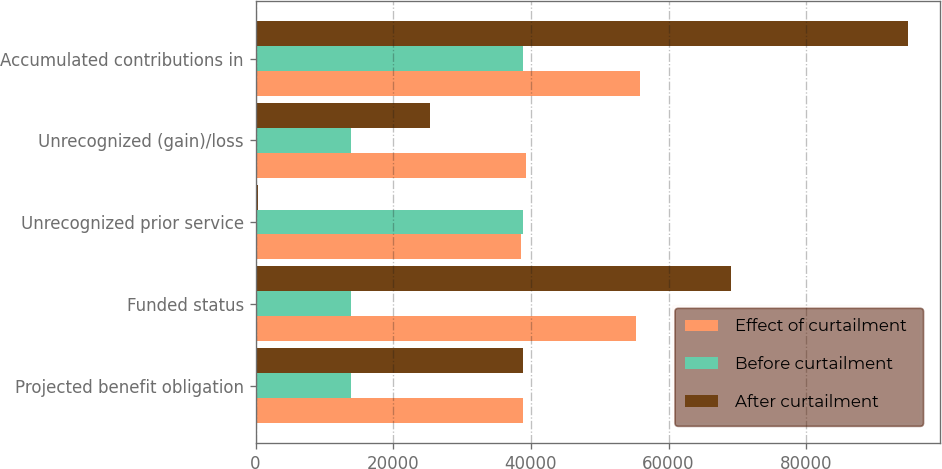<chart> <loc_0><loc_0><loc_500><loc_500><stacked_bar_chart><ecel><fcel>Projected benefit obligation<fcel>Funded status<fcel>Unrecognized prior service<fcel>Unrecognized (gain)/loss<fcel>Accumulated contributions in<nl><fcel>Effect of curtailment<fcel>38891<fcel>55199<fcel>38608<fcel>39249<fcel>55840<nl><fcel>Before curtailment<fcel>13897<fcel>13897<fcel>38891<fcel>13897<fcel>38891<nl><fcel>After curtailment<fcel>38891<fcel>69096<fcel>284<fcel>25352<fcel>94732<nl></chart> 